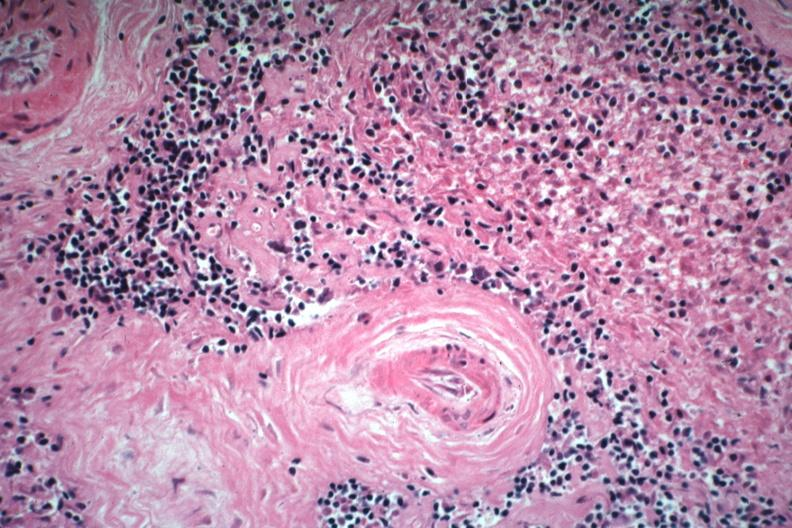does this image show two basophilic bodies and periarterial fibrosis excellent example of this rarely seen lupus lesion?
Answer the question using a single word or phrase. Yes 